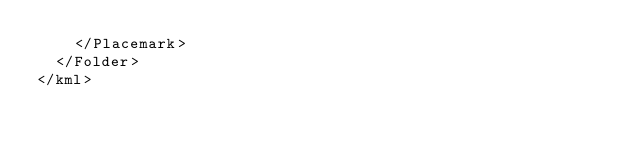Convert code to text. <code><loc_0><loc_0><loc_500><loc_500><_XML_>    </Placemark>
  </Folder>
</kml>
</code> 